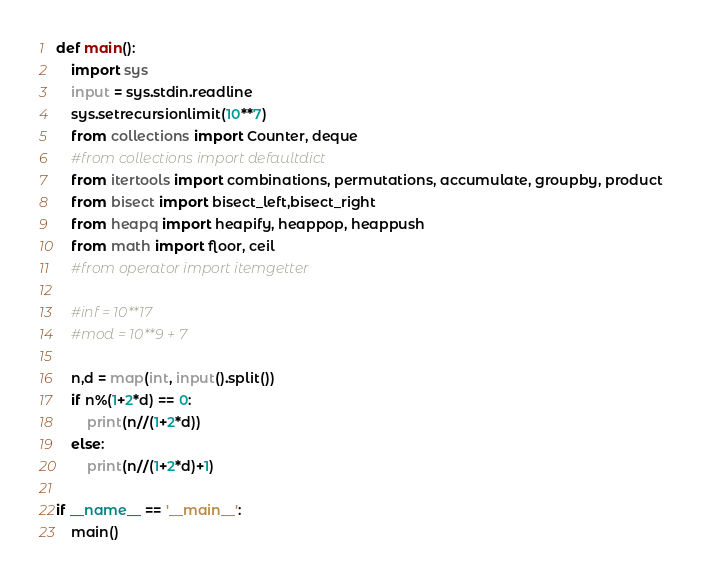Convert code to text. <code><loc_0><loc_0><loc_500><loc_500><_Python_>def main():
    import sys
    input = sys.stdin.readline
    sys.setrecursionlimit(10**7)
    from collections import Counter, deque
    #from collections import defaultdict
    from itertools import combinations, permutations, accumulate, groupby, product
    from bisect import bisect_left,bisect_right
    from heapq import heapify, heappop, heappush
    from math import floor, ceil
    #from operator import itemgetter

    #inf = 10**17
    #mod = 10**9 + 7

    n,d = map(int, input().split())
    if n%(1+2*d) == 0:
        print(n//(1+2*d))
    else:
        print(n//(1+2*d)+1)

if __name__ == '__main__':
    main()</code> 